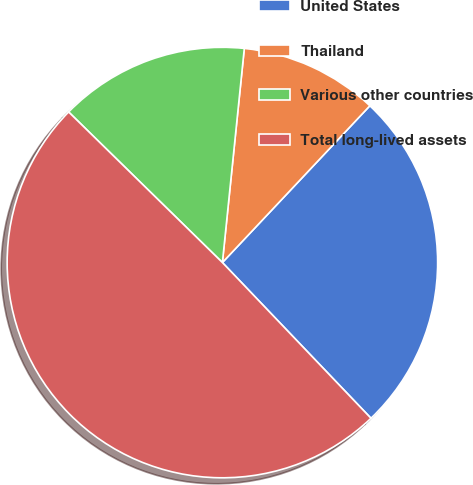<chart> <loc_0><loc_0><loc_500><loc_500><pie_chart><fcel>United States<fcel>Thailand<fcel>Various other countries<fcel>Total long-lived assets<nl><fcel>25.86%<fcel>10.39%<fcel>14.29%<fcel>49.46%<nl></chart> 